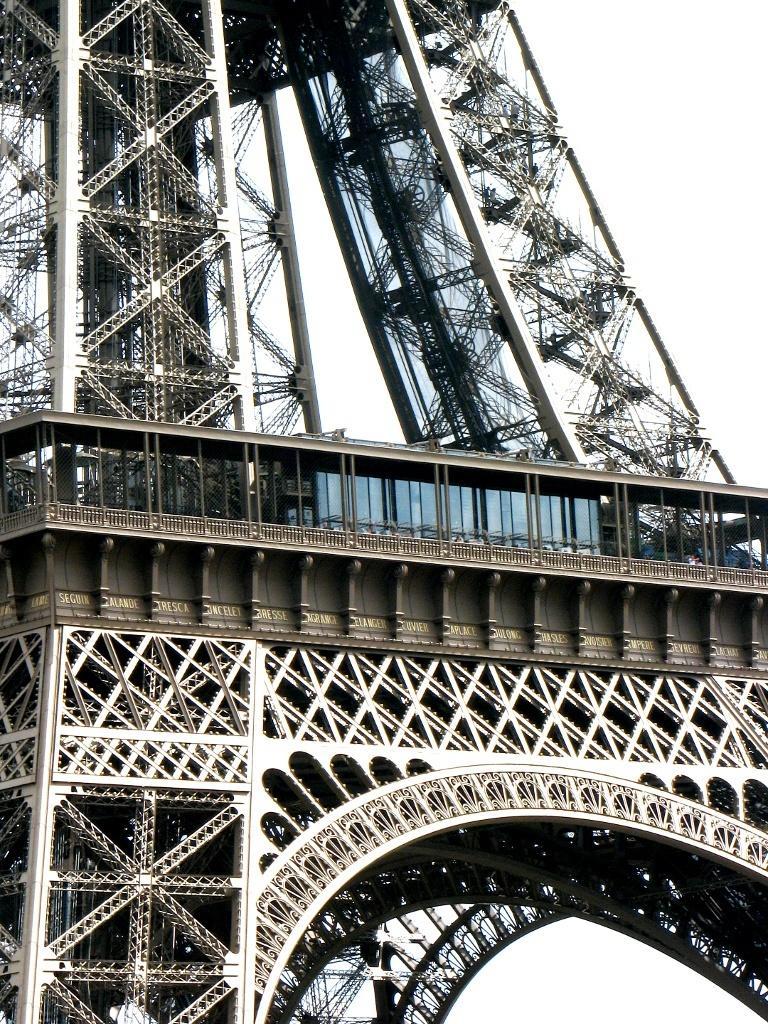Describe this image in one or two sentences. In the picture we can see a part of Eiffel tower and behind it we can see a sky. 